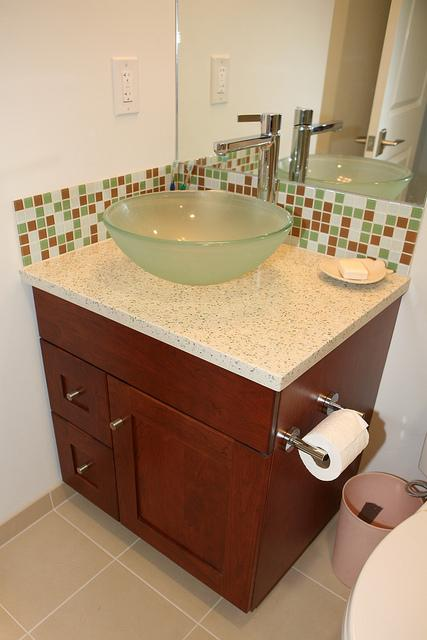What is the green bowl on the counter used for? Please explain your reasoning. catching water. This is a bathroom, not a kitchen or dining room. the bowl is below a faucet. 